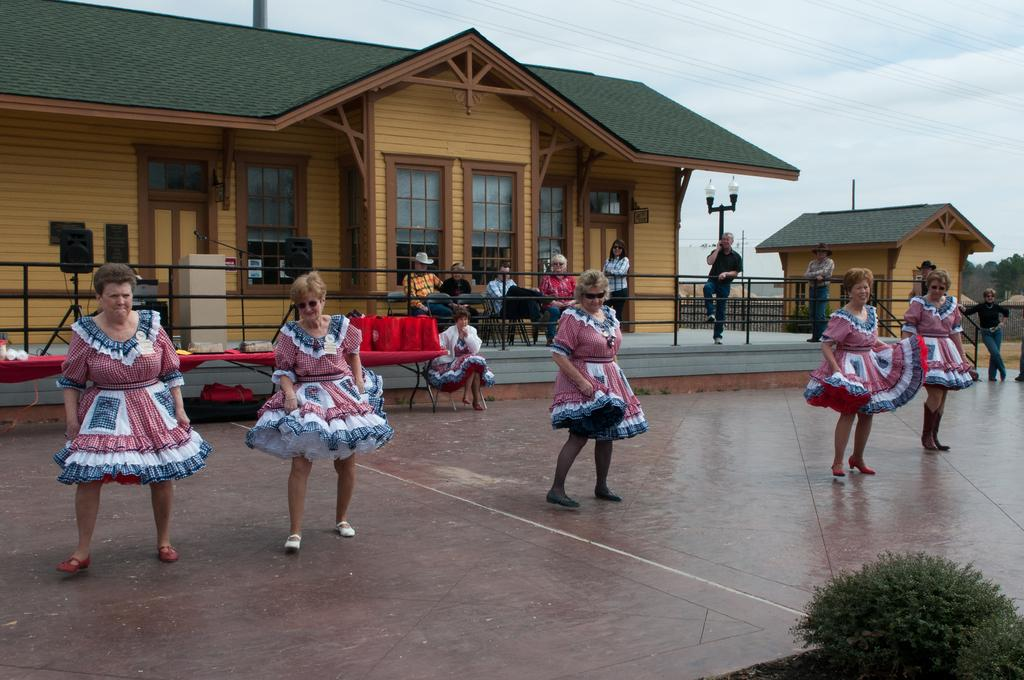What are the people in the image doing? There is a group of people dancing in the image. Are there any other people in the image who are not dancing? Yes, there is a group of people sitting on chairs in the image. What type of structures can be seen in the image? Houses are visible in the image. How are the houses illuminated? The houses are lighted. What furniture is present in the image? There is a table in the image. What type of natural elements can be seen in the image? Trees are present in the image. What is visible in the background of the image? The sky is visible in the background of the image. What type of pickle is being used as a chess piece in the image? There is no pickle or chess game present in the image. How many yams are visible on the table in the image? There are no yams present in the image. 